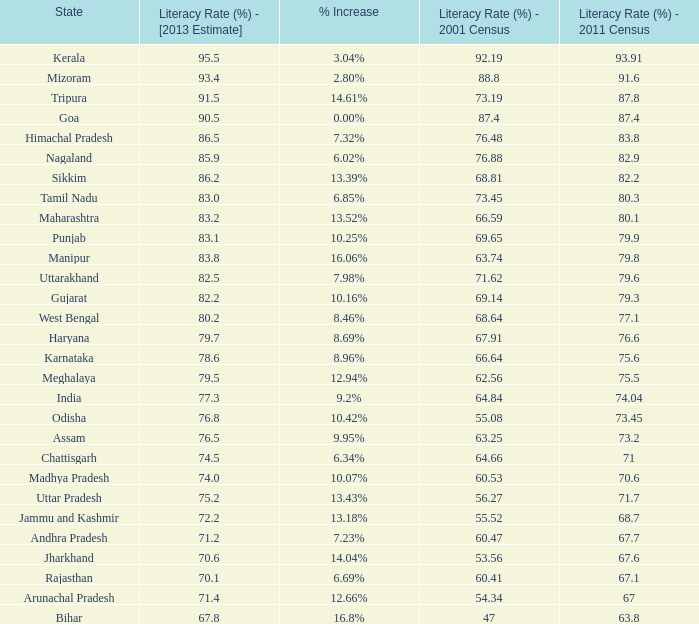What is the average increase in literacy for the states that had a rate higher than 73.2% in 2011, less than 68.81% in 2001, and an estimate of 76.8% for 2013? 10.42%. 